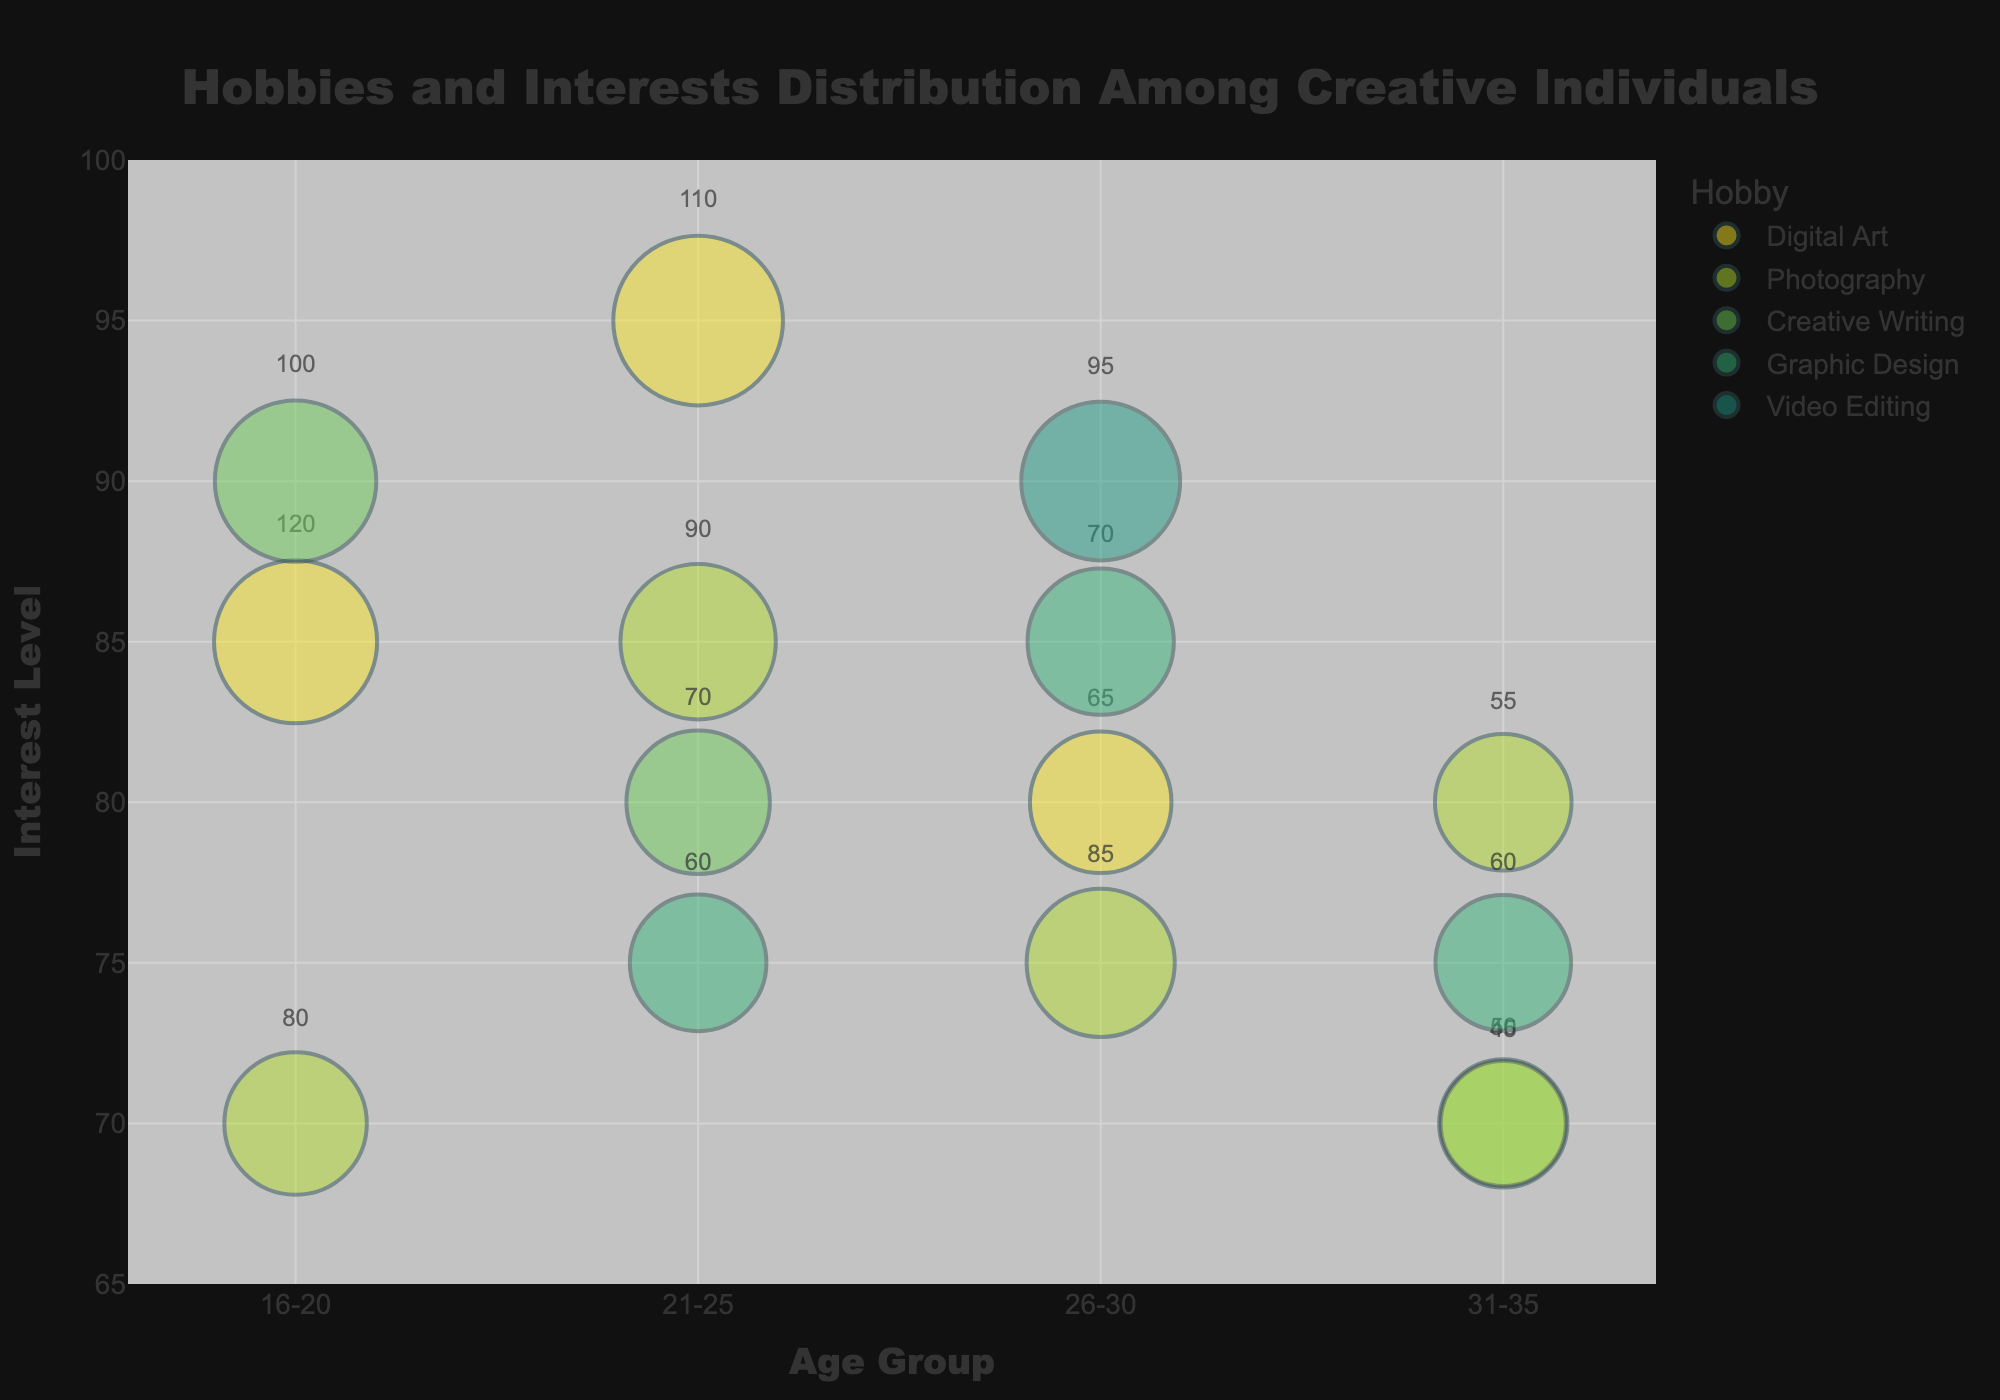What is the title of the chart? The title is displayed at the top of the chart, clearly indicating the subject of the graph.
Answer: Hobbies and Interests Distribution Among Creative Individuals Which age group has the highest average interest level in Digital Art? To determine the average interest level, identify all interest levels for Digital Art and calculate their mean for each age group. For the 16-20 age group, it is 85; for 21-25, it is 95; for 26-30, it is 80; for 31-35, it is 70. The highest is 95 for the 21-25 age group.
Answer: 21-25 How many hobbies are represented in the 21-25 age group? Count the distinct hobbies listed in the 21-25 age group: Digital Art, Photography, Creative Writing, and Graphic Design.
Answer: 4 Which hobby has the largest bubble size in the 26-30 age group? Look at the bubble sizes for each hobby in the 26-30 age group: Photography (80), Video Editing (92), Graphic Design (78), Digital Art (73). Video Editing has the largest bubble size.
Answer: Video Editing What is the average interest level across all hobbies for the 31-35 age group? Sum the interest levels for all hobbies in the 31-35 age group and divide by the number of hobbies: (70 + 80 + 70 + 75) / 4 = 73.75.
Answer: 73.75 Which age group shows the highest number of individuals interested in Creative Writing? Compare the number of individuals interested in Creative Writing across the age groups: 16-20 (100), 21-25 (70), 31-35 (45). The highest number is 100 in the 16-20 age group.
Answer: 16-20 Which hobby has the lowest interest level in the 21-25 age group? Check the interest levels for each hobby in the 21-25 age group: Digital Art (95), Photography (85), Creative Writing (80), Graphic Design (75). The lowest interest level is 75 in Graphic Design.
Answer: Graphic Design What is the total number of individuals interested in Photography across all age groups? Sum the number of individuals interested in Photography across all age groups: 80 (16-20) + 90 (21-25) + 85 (26-30) + 55 (31-35) = 310.
Answer: 310 Which hobby in the 26-30 age group has a higher interest level, Digital Art or Graphic Design? Compare the interest levels of Digital Art (80) and Graphic Design (85) in the 26-30 age group. Graphic Design has a higher level.
Answer: Graphic Design What is the interest level difference between Digital Art in the 16-20 and 31-35 age groups? Subtract the interest level of Digital Art in the 31-35 age group (70) from that in the 16-20 age group (85): 85 - 70 = 15.
Answer: 15 